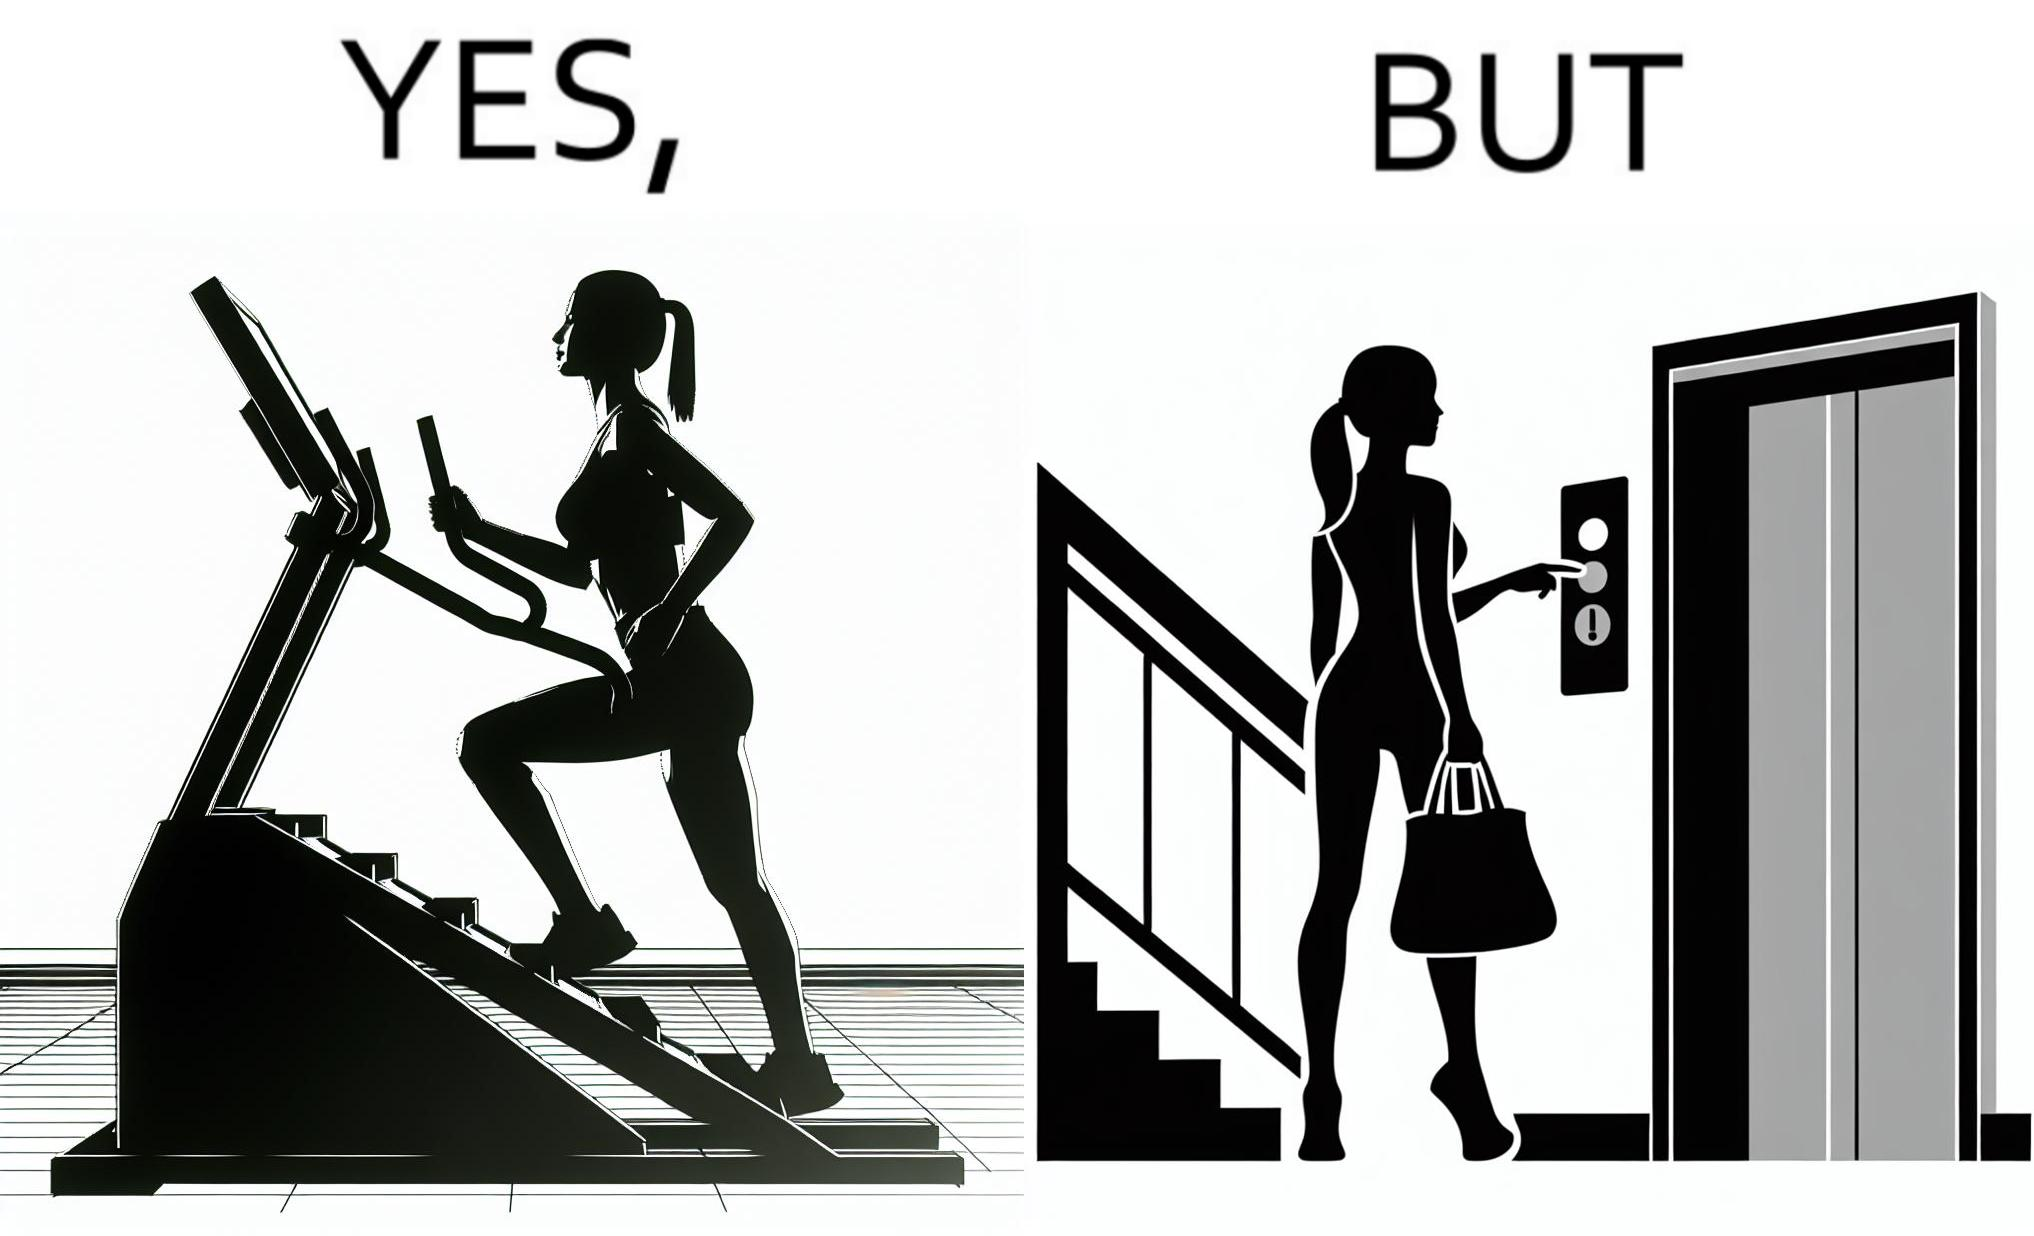Why is this image considered satirical? The image is ironic, because in the left image a woman is seen using the stair climber machine at the gym but the same woman is not ready to climb up some stairs for going to the gym and is calling for the lift 